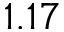<formula> <loc_0><loc_0><loc_500><loc_500>1 . 1 7</formula> 